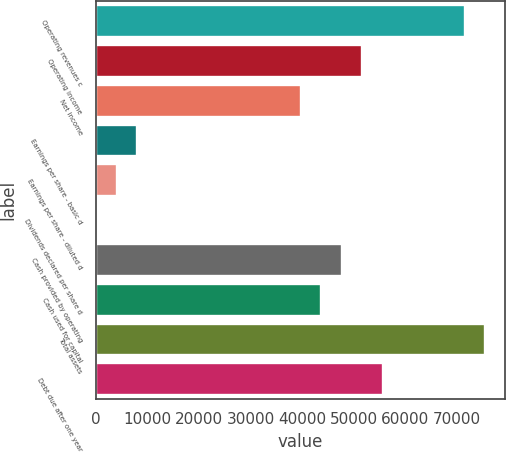Convert chart to OTSL. <chart><loc_0><loc_0><loc_500><loc_500><bar_chart><fcel>Operating revenues c<fcel>Operating income<fcel>Net income<fcel>Earnings per share - basic d<fcel>Earnings per share - diluted d<fcel>Dividends declared per share d<fcel>Cash provided by operating<fcel>Cash used for capital<fcel>Total assets<fcel>Debt due after one year<nl><fcel>71498.8<fcel>51638.3<fcel>39722<fcel>7945.18<fcel>3973.08<fcel>0.98<fcel>47666.2<fcel>43694.1<fcel>75470.9<fcel>55610.4<nl></chart> 